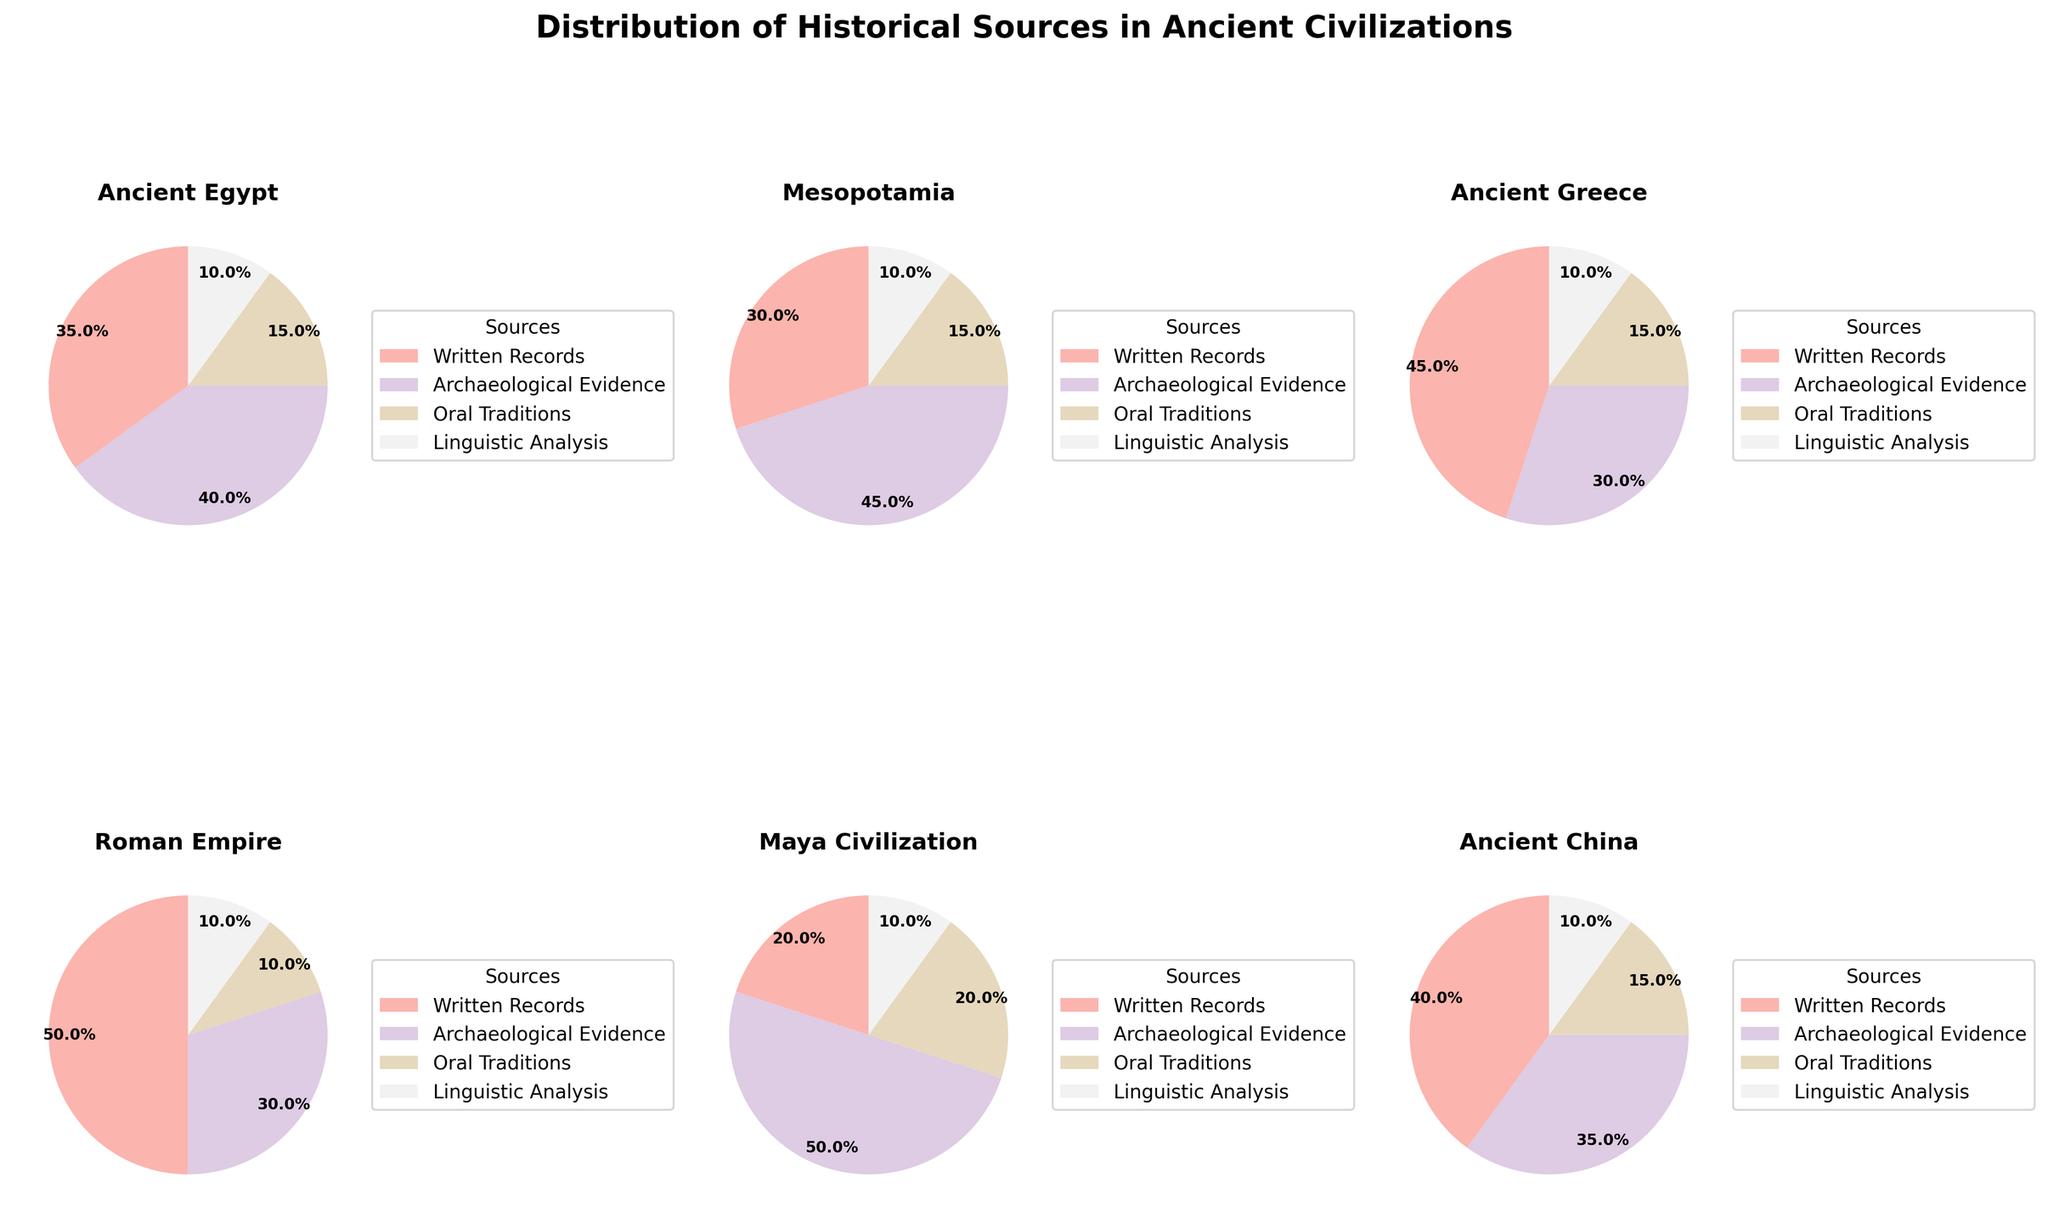What is the title of the figure? The title is usually found at the top of the figure. In this case, it's clearly displayed above the subplots.
Answer: Distribution of Historical Sources in Ancient Civilizations Which civilization relies the most on Archaeological Evidence? By examining the sections of each pie chart dedicated to Archaeological Evidence and comparing their sizes, it is evident that the Maya Civilization has the largest section for this category.
Answer: Maya Civilization What percentage of Written Records does the Roman Empire use? The Roman Empire pie chart shows that Written Records make up half of its sources, which translates to 50%.
Answer: 50% Which civilization has the smallest proportion of Oral Traditions? By comparing each pie chart's section for Oral Traditions and identifying the smaller ones, it is clear that the Roman Empire has the smallest proportion allocated for Oral Traditions.
Answer: Roman Empire What is the combined percentage of Archaeological Evidence for Ancient China and Mesopotamia? Add the percentage values for Archaeological Evidence: Ancient China (35%) and Mesopotamia (45%). 35% + 45% = 80%
Answer: 80% Which two civilizations have an equal percentage of Linguistic Analysis? By examining the sections of each pie chart for Linguistic Analysis and comparing their sizes, it is clear that Ancient Egypt, Mesopotamia, Ancient Greece, the Roman Empire, the Maya Civilization, and Ancient China all show 10% allocated to Linguistic Analysis.
Answer: All Civilizations Which civilization uses the highest proportion of Written Records compared to others? By comparing the pie chart sections for Written Records, we observe that the Roman Empire has the highest proportion (50%).
Answer: Roman Empire For Ancient Greece, how does the percentage of Archaeological Evidence compare to the percentage of Written Records? In the Ancient Greece pie chart, Written Records constitute 45% and Archaeological Evidence represents 30%. Therefore, Written Records are 15% higher than Archaeological Evidence.
Answer: 15% higher If we sum the percentages of all sources for Ancient Egypt, does it add up to 100%? Adding up all the slices for Ancient Egypt: Written Records (35%), Archaeological Evidence (40%), Oral Traditions (15%), Linguistic Analysis (10%) sums up to 100%. 35% + 40% + 15% + 10% = 100%
Answer: Yes How do Oral Traditions compare to Archaeological Evidence across all civilizations in general? By scanning across all pie charts, we notice that Archaeological Evidence consistently occupies a larger section than Oral Traditions, suggesting a general reliance more on Archaeological Evidence across ancient civilizations.
Answer: Archaeological Evidence is more prominent 